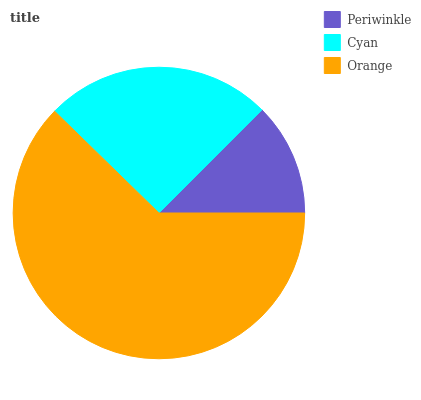Is Periwinkle the minimum?
Answer yes or no. Yes. Is Orange the maximum?
Answer yes or no. Yes. Is Cyan the minimum?
Answer yes or no. No. Is Cyan the maximum?
Answer yes or no. No. Is Cyan greater than Periwinkle?
Answer yes or no. Yes. Is Periwinkle less than Cyan?
Answer yes or no. Yes. Is Periwinkle greater than Cyan?
Answer yes or no. No. Is Cyan less than Periwinkle?
Answer yes or no. No. Is Cyan the high median?
Answer yes or no. Yes. Is Cyan the low median?
Answer yes or no. Yes. Is Orange the high median?
Answer yes or no. No. Is Orange the low median?
Answer yes or no. No. 